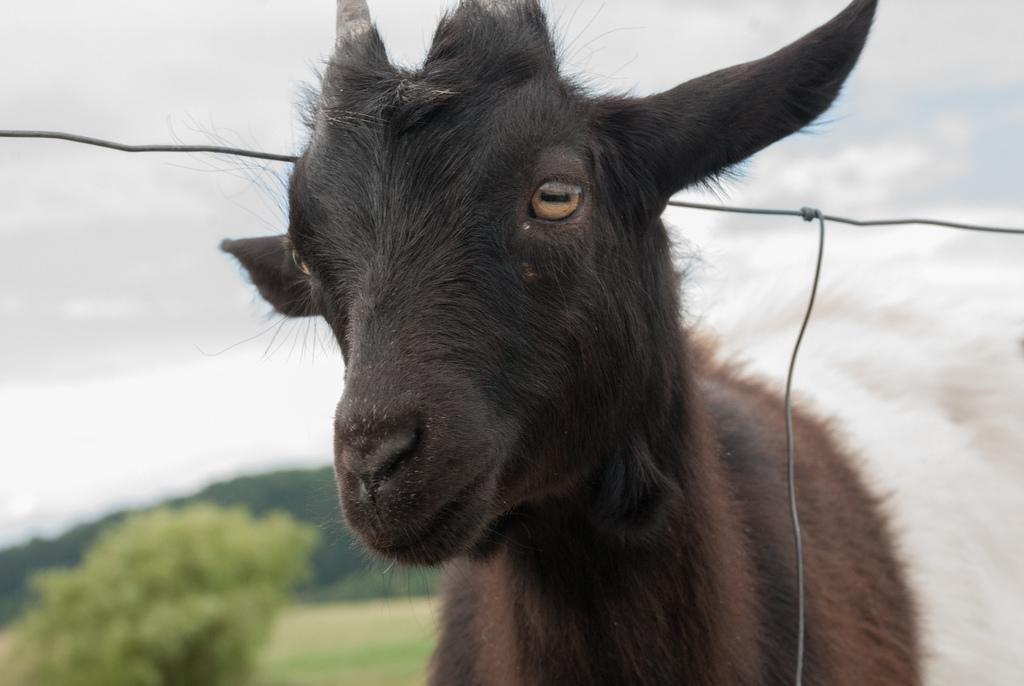Describe this image in one or two sentences. In this picture we can see a goat and in the background we can see trees and the sky. 